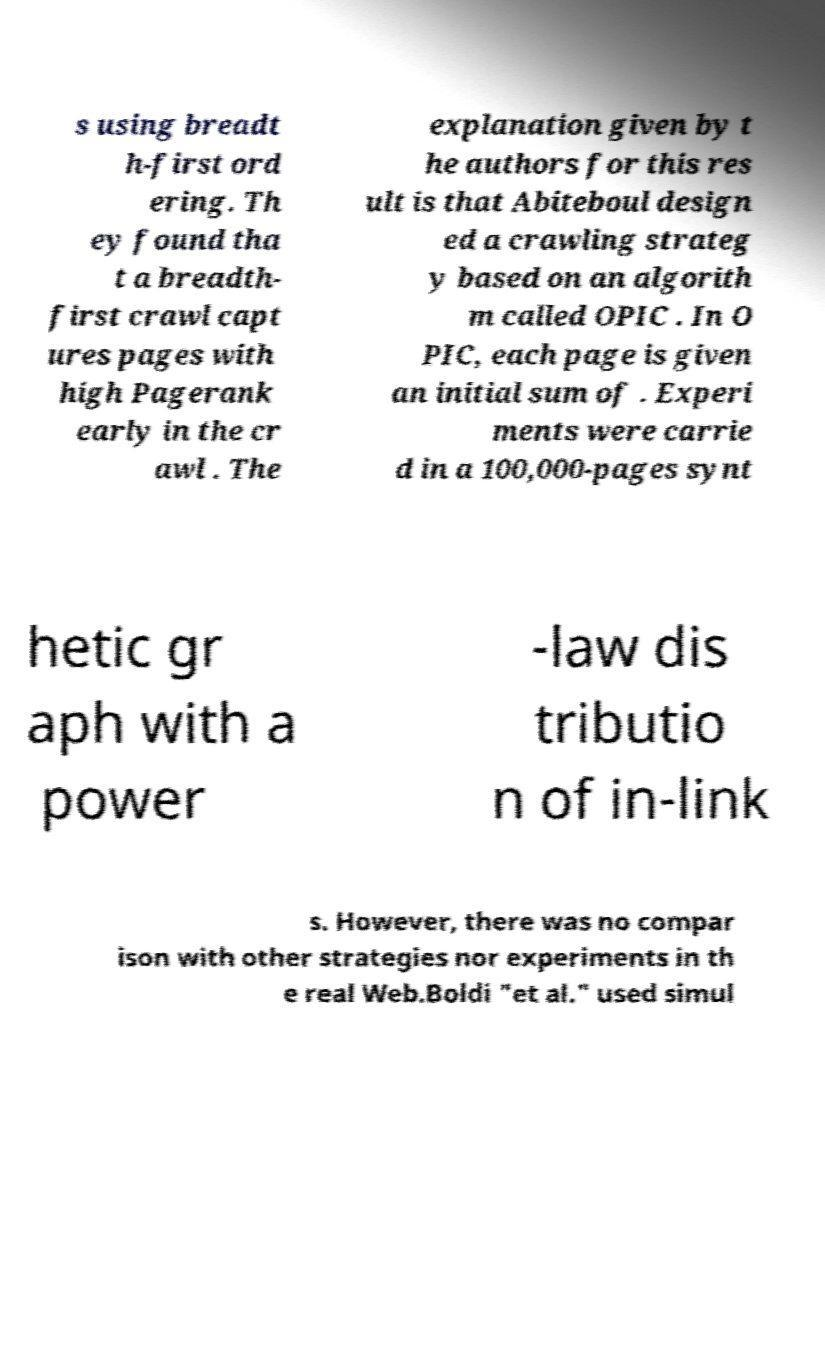I need the written content from this picture converted into text. Can you do that? s using breadt h-first ord ering. Th ey found tha t a breadth- first crawl capt ures pages with high Pagerank early in the cr awl . The explanation given by t he authors for this res ult is that Abiteboul design ed a crawling strateg y based on an algorith m called OPIC . In O PIC, each page is given an initial sum of . Experi ments were carrie d in a 100,000-pages synt hetic gr aph with a power -law dis tributio n of in-link s. However, there was no compar ison with other strategies nor experiments in th e real Web.Boldi "et al." used simul 